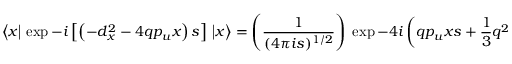Convert formula to latex. <formula><loc_0><loc_0><loc_500><loc_500>\left \langle x \left | \, \exp - i \left [ \left ( - d _ { x } ^ { 2 } - 4 q p _ { u } x \right ) s \right ] \, \right | x \right \rangle = \left ( { \frac { 1 } { ( 4 \pi i s ) ^ { 1 / 2 } } } \right ) \, \exp - 4 i \left ( q p _ { u } x s + { \frac { 1 } { 3 } } q ^ { 2 } p _ { u } ^ { 2 } s ^ { 3 } \right ) .</formula> 